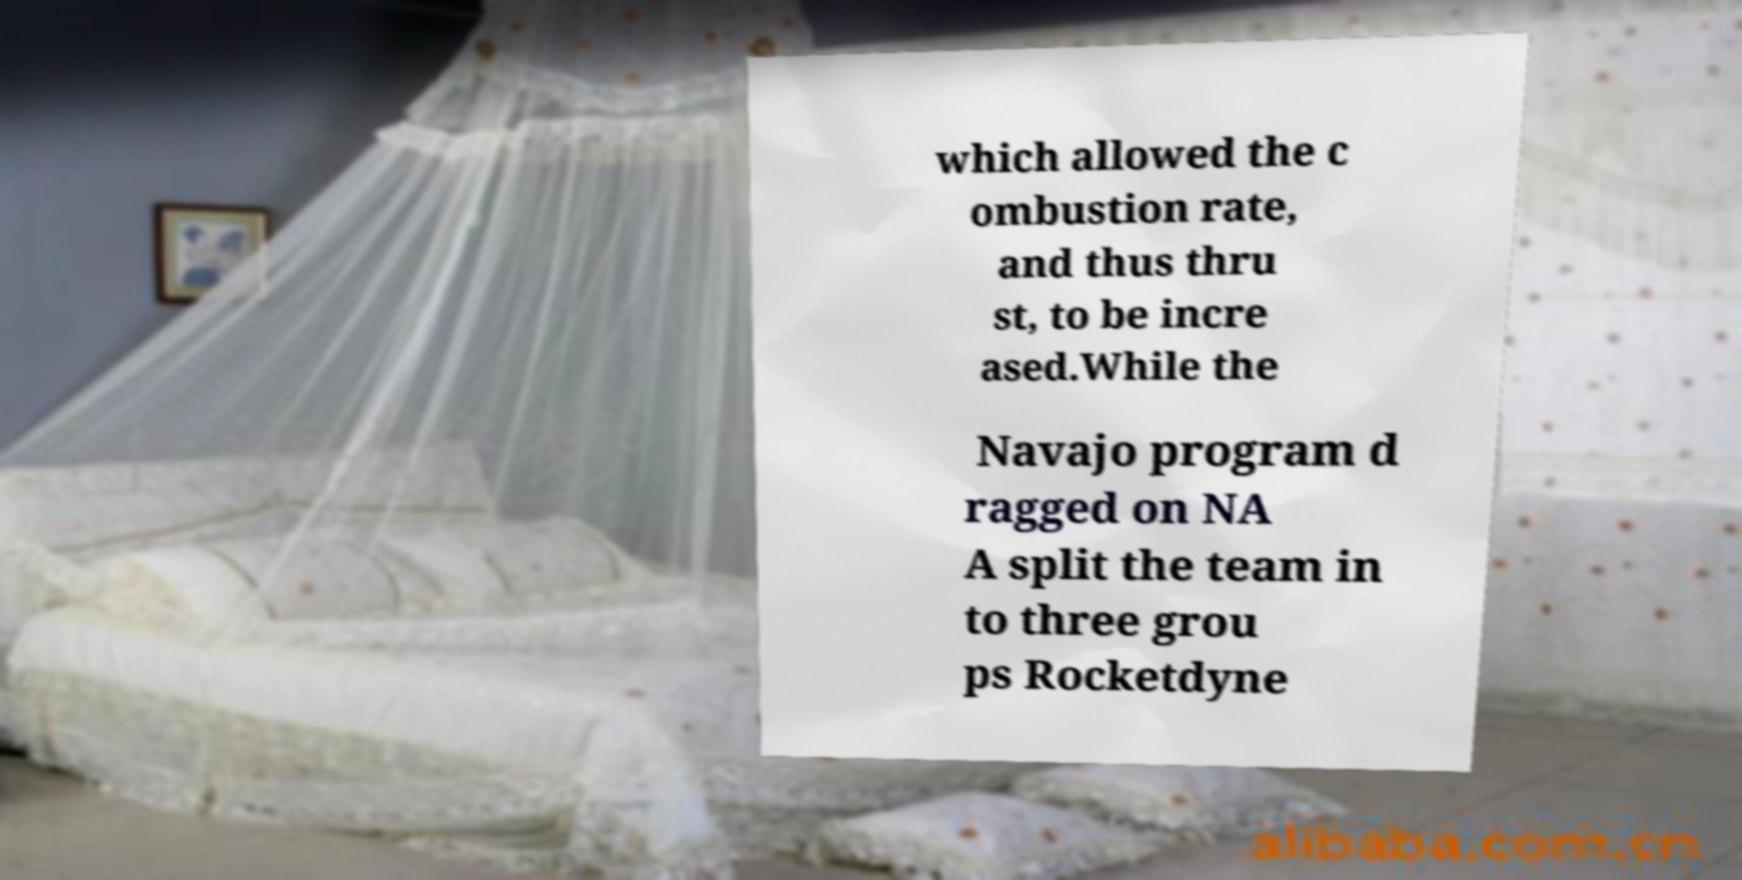There's text embedded in this image that I need extracted. Can you transcribe it verbatim? which allowed the c ombustion rate, and thus thru st, to be incre ased.While the Navajo program d ragged on NA A split the team in to three grou ps Rocketdyne 